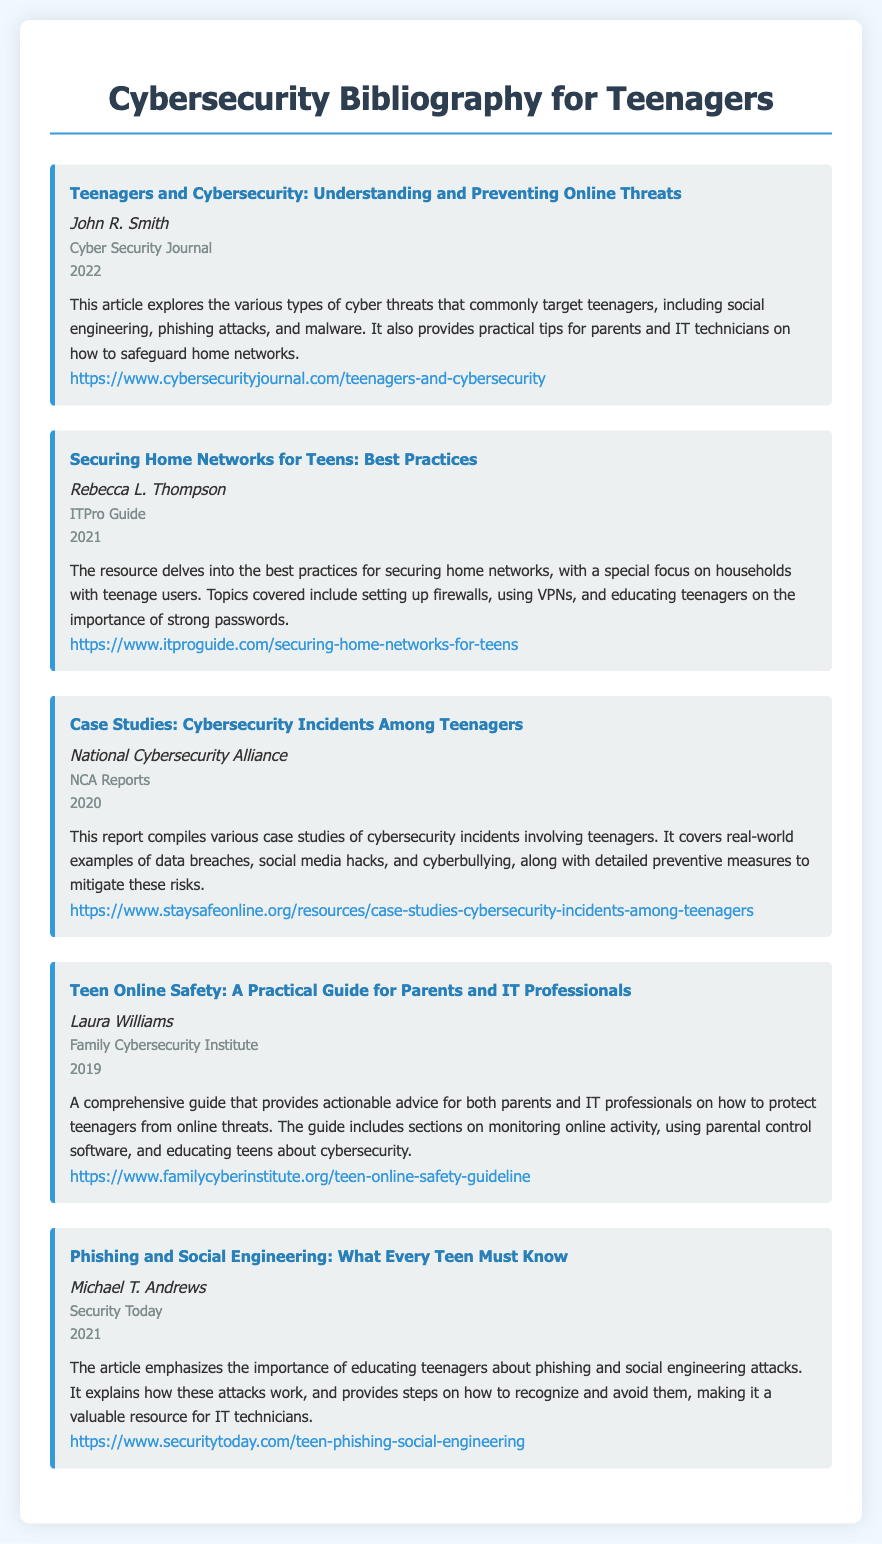What is the title of the first bibliography item? The title of the first bibliography item is presented in bold font at the beginning of the item.
Answer: Teenagers and Cybersecurity: Understanding and Preventing Online Threats Who authored the article about phishing and social engineering? The author's name is listed below the title in italics, specifically for the phishing and social engineering item.
Answer: Michael T. Andrews In which year was the guide for parents and IT professionals published? The publication year is noted in a separate line for each bibliography item.
Answer: 2019 What publisher released the report compiling case studies? The publisher's name appears below the author's name for the third bibliography item.
Answer: NCA Reports Which article discusses best practices for securing home networks? The article that focuses on best practices is identified by its title within the bibliography.
Answer: Securing Home Networks for Teens: Best Practices What common attack vector is highlighted in both the first and last bibliography items? Both items touch on the theme of online threats and security challenges, specifically targeting teenagers.
Answer: Online threats How many bibliography items are included in the document? The total number of bibliography items can be counted by identifying the separate sections or entries in the document.
Answer: 5 What is the primary focus of the bibliography? The focus is described in the title at the top of the document, relating specifically to cybersecurity for a certain demographic.
Answer: Cybersecurity for Teenagers Which URL links to the article about case studies of cybersecurity incidents? The URL is provided at the end of each bibliography item to give access to additional information on the subject.
Answer: https://www.staysafeonline.org/resources/case-studies-cybersecurity-incidents-among-teenagers 